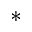Convert formula to latex. <formula><loc_0><loc_0><loc_500><loc_500>\ast</formula> 